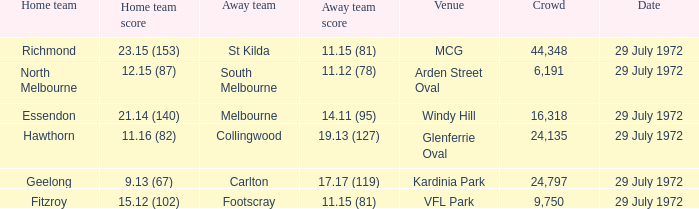When did the offsite team footscray accomplish 1 29 July 1972. 